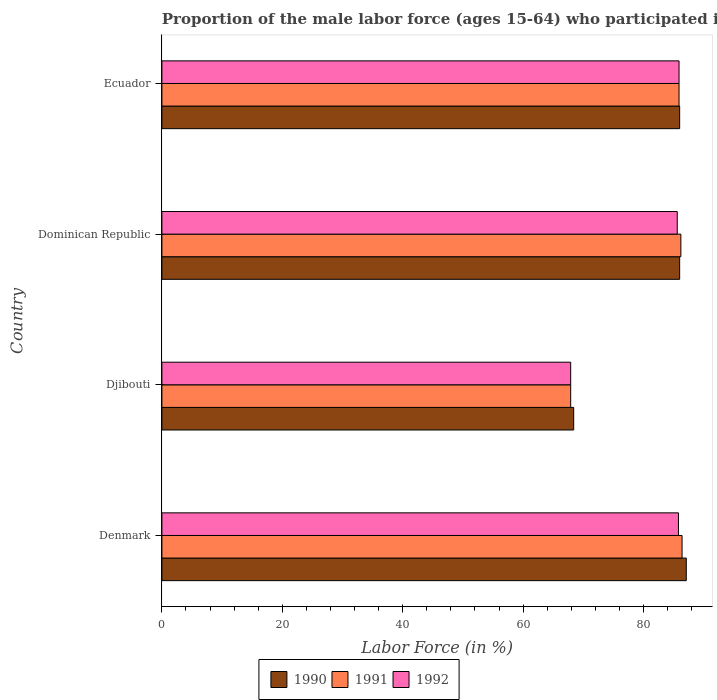How many different coloured bars are there?
Your answer should be compact. 3. How many groups of bars are there?
Provide a short and direct response. 4. Are the number of bars per tick equal to the number of legend labels?
Provide a succinct answer. Yes. Are the number of bars on each tick of the Y-axis equal?
Offer a very short reply. Yes. How many bars are there on the 1st tick from the bottom?
Keep it short and to the point. 3. What is the label of the 3rd group of bars from the top?
Give a very brief answer. Djibouti. Across all countries, what is the maximum proportion of the male labor force who participated in production in 1992?
Keep it short and to the point. 85.9. Across all countries, what is the minimum proportion of the male labor force who participated in production in 1991?
Offer a terse response. 67.9. In which country was the proportion of the male labor force who participated in production in 1991 maximum?
Provide a short and direct response. Denmark. In which country was the proportion of the male labor force who participated in production in 1992 minimum?
Give a very brief answer. Djibouti. What is the total proportion of the male labor force who participated in production in 1992 in the graph?
Provide a succinct answer. 325.2. What is the difference between the proportion of the male labor force who participated in production in 1991 in Djibouti and that in Dominican Republic?
Your answer should be compact. -18.3. What is the difference between the proportion of the male labor force who participated in production in 1992 in Denmark and the proportion of the male labor force who participated in production in 1990 in Dominican Republic?
Keep it short and to the point. -0.2. What is the average proportion of the male labor force who participated in production in 1992 per country?
Offer a very short reply. 81.3. What is the difference between the proportion of the male labor force who participated in production in 1990 and proportion of the male labor force who participated in production in 1992 in Dominican Republic?
Keep it short and to the point. 0.4. In how many countries, is the proportion of the male labor force who participated in production in 1990 greater than 28 %?
Give a very brief answer. 4. What is the ratio of the proportion of the male labor force who participated in production in 1991 in Djibouti to that in Dominican Republic?
Offer a very short reply. 0.79. Is the proportion of the male labor force who participated in production in 1990 in Denmark less than that in Ecuador?
Your response must be concise. No. Is the difference between the proportion of the male labor force who participated in production in 1990 in Denmark and Djibouti greater than the difference between the proportion of the male labor force who participated in production in 1992 in Denmark and Djibouti?
Give a very brief answer. Yes. What is the difference between the highest and the second highest proportion of the male labor force who participated in production in 1991?
Your response must be concise. 0.2. What is the difference between the highest and the lowest proportion of the male labor force who participated in production in 1992?
Keep it short and to the point. 18. In how many countries, is the proportion of the male labor force who participated in production in 1990 greater than the average proportion of the male labor force who participated in production in 1990 taken over all countries?
Keep it short and to the point. 3. What does the 3rd bar from the bottom in Ecuador represents?
Provide a short and direct response. 1992. What is the difference between two consecutive major ticks on the X-axis?
Your answer should be compact. 20. Are the values on the major ticks of X-axis written in scientific E-notation?
Your response must be concise. No. Does the graph contain any zero values?
Ensure brevity in your answer.  No. Where does the legend appear in the graph?
Keep it short and to the point. Bottom center. What is the title of the graph?
Offer a terse response. Proportion of the male labor force (ages 15-64) who participated in production. What is the Labor Force (in %) of 1990 in Denmark?
Your response must be concise. 87.1. What is the Labor Force (in %) of 1991 in Denmark?
Ensure brevity in your answer.  86.4. What is the Labor Force (in %) of 1992 in Denmark?
Offer a terse response. 85.8. What is the Labor Force (in %) in 1990 in Djibouti?
Ensure brevity in your answer.  68.4. What is the Labor Force (in %) in 1991 in Djibouti?
Your answer should be compact. 67.9. What is the Labor Force (in %) in 1992 in Djibouti?
Your answer should be very brief. 67.9. What is the Labor Force (in %) in 1990 in Dominican Republic?
Provide a succinct answer. 86. What is the Labor Force (in %) of 1991 in Dominican Republic?
Your response must be concise. 86.2. What is the Labor Force (in %) of 1992 in Dominican Republic?
Your response must be concise. 85.6. What is the Labor Force (in %) of 1991 in Ecuador?
Offer a very short reply. 85.9. What is the Labor Force (in %) of 1992 in Ecuador?
Provide a short and direct response. 85.9. Across all countries, what is the maximum Labor Force (in %) in 1990?
Your answer should be compact. 87.1. Across all countries, what is the maximum Labor Force (in %) in 1991?
Ensure brevity in your answer.  86.4. Across all countries, what is the maximum Labor Force (in %) of 1992?
Provide a short and direct response. 85.9. Across all countries, what is the minimum Labor Force (in %) in 1990?
Make the answer very short. 68.4. Across all countries, what is the minimum Labor Force (in %) in 1991?
Make the answer very short. 67.9. Across all countries, what is the minimum Labor Force (in %) of 1992?
Provide a succinct answer. 67.9. What is the total Labor Force (in %) of 1990 in the graph?
Your answer should be very brief. 327.5. What is the total Labor Force (in %) of 1991 in the graph?
Keep it short and to the point. 326.4. What is the total Labor Force (in %) of 1992 in the graph?
Make the answer very short. 325.2. What is the difference between the Labor Force (in %) of 1990 in Denmark and that in Djibouti?
Ensure brevity in your answer.  18.7. What is the difference between the Labor Force (in %) in 1991 in Denmark and that in Djibouti?
Make the answer very short. 18.5. What is the difference between the Labor Force (in %) of 1992 in Denmark and that in Djibouti?
Make the answer very short. 17.9. What is the difference between the Labor Force (in %) of 1991 in Denmark and that in Dominican Republic?
Your response must be concise. 0.2. What is the difference between the Labor Force (in %) in 1992 in Denmark and that in Dominican Republic?
Offer a very short reply. 0.2. What is the difference between the Labor Force (in %) in 1991 in Denmark and that in Ecuador?
Your answer should be very brief. 0.5. What is the difference between the Labor Force (in %) of 1992 in Denmark and that in Ecuador?
Ensure brevity in your answer.  -0.1. What is the difference between the Labor Force (in %) in 1990 in Djibouti and that in Dominican Republic?
Your response must be concise. -17.6. What is the difference between the Labor Force (in %) in 1991 in Djibouti and that in Dominican Republic?
Your answer should be very brief. -18.3. What is the difference between the Labor Force (in %) in 1992 in Djibouti and that in Dominican Republic?
Your answer should be very brief. -17.7. What is the difference between the Labor Force (in %) of 1990 in Djibouti and that in Ecuador?
Provide a succinct answer. -17.6. What is the difference between the Labor Force (in %) of 1991 in Djibouti and that in Ecuador?
Offer a very short reply. -18. What is the difference between the Labor Force (in %) in 1992 in Djibouti and that in Ecuador?
Your response must be concise. -18. What is the difference between the Labor Force (in %) in 1991 in Dominican Republic and that in Ecuador?
Make the answer very short. 0.3. What is the difference between the Labor Force (in %) in 1991 in Denmark and the Labor Force (in %) in 1992 in Djibouti?
Your answer should be compact. 18.5. What is the difference between the Labor Force (in %) of 1990 in Denmark and the Labor Force (in %) of 1991 in Ecuador?
Provide a short and direct response. 1.2. What is the difference between the Labor Force (in %) in 1990 in Denmark and the Labor Force (in %) in 1992 in Ecuador?
Provide a succinct answer. 1.2. What is the difference between the Labor Force (in %) in 1990 in Djibouti and the Labor Force (in %) in 1991 in Dominican Republic?
Make the answer very short. -17.8. What is the difference between the Labor Force (in %) of 1990 in Djibouti and the Labor Force (in %) of 1992 in Dominican Republic?
Offer a terse response. -17.2. What is the difference between the Labor Force (in %) in 1991 in Djibouti and the Labor Force (in %) in 1992 in Dominican Republic?
Keep it short and to the point. -17.7. What is the difference between the Labor Force (in %) of 1990 in Djibouti and the Labor Force (in %) of 1991 in Ecuador?
Your answer should be very brief. -17.5. What is the difference between the Labor Force (in %) in 1990 in Djibouti and the Labor Force (in %) in 1992 in Ecuador?
Offer a very short reply. -17.5. What is the difference between the Labor Force (in %) of 1991 in Djibouti and the Labor Force (in %) of 1992 in Ecuador?
Your answer should be very brief. -18. What is the difference between the Labor Force (in %) of 1990 in Dominican Republic and the Labor Force (in %) of 1991 in Ecuador?
Give a very brief answer. 0.1. What is the difference between the Labor Force (in %) in 1990 in Dominican Republic and the Labor Force (in %) in 1992 in Ecuador?
Your response must be concise. 0.1. What is the difference between the Labor Force (in %) of 1991 in Dominican Republic and the Labor Force (in %) of 1992 in Ecuador?
Your answer should be compact. 0.3. What is the average Labor Force (in %) of 1990 per country?
Your response must be concise. 81.88. What is the average Labor Force (in %) of 1991 per country?
Your answer should be very brief. 81.6. What is the average Labor Force (in %) of 1992 per country?
Your response must be concise. 81.3. What is the difference between the Labor Force (in %) in 1991 and Labor Force (in %) in 1992 in Djibouti?
Your answer should be very brief. 0. What is the difference between the Labor Force (in %) of 1990 and Labor Force (in %) of 1991 in Dominican Republic?
Give a very brief answer. -0.2. What is the difference between the Labor Force (in %) of 1990 and Labor Force (in %) of 1992 in Dominican Republic?
Ensure brevity in your answer.  0.4. What is the ratio of the Labor Force (in %) of 1990 in Denmark to that in Djibouti?
Your answer should be very brief. 1.27. What is the ratio of the Labor Force (in %) of 1991 in Denmark to that in Djibouti?
Provide a succinct answer. 1.27. What is the ratio of the Labor Force (in %) of 1992 in Denmark to that in Djibouti?
Offer a very short reply. 1.26. What is the ratio of the Labor Force (in %) in 1990 in Denmark to that in Dominican Republic?
Offer a very short reply. 1.01. What is the ratio of the Labor Force (in %) of 1991 in Denmark to that in Dominican Republic?
Give a very brief answer. 1. What is the ratio of the Labor Force (in %) of 1990 in Denmark to that in Ecuador?
Keep it short and to the point. 1.01. What is the ratio of the Labor Force (in %) in 1990 in Djibouti to that in Dominican Republic?
Ensure brevity in your answer.  0.8. What is the ratio of the Labor Force (in %) in 1991 in Djibouti to that in Dominican Republic?
Give a very brief answer. 0.79. What is the ratio of the Labor Force (in %) in 1992 in Djibouti to that in Dominican Republic?
Provide a succinct answer. 0.79. What is the ratio of the Labor Force (in %) of 1990 in Djibouti to that in Ecuador?
Ensure brevity in your answer.  0.8. What is the ratio of the Labor Force (in %) in 1991 in Djibouti to that in Ecuador?
Make the answer very short. 0.79. What is the ratio of the Labor Force (in %) in 1992 in Djibouti to that in Ecuador?
Provide a succinct answer. 0.79. What is the difference between the highest and the lowest Labor Force (in %) in 1991?
Provide a short and direct response. 18.5. 